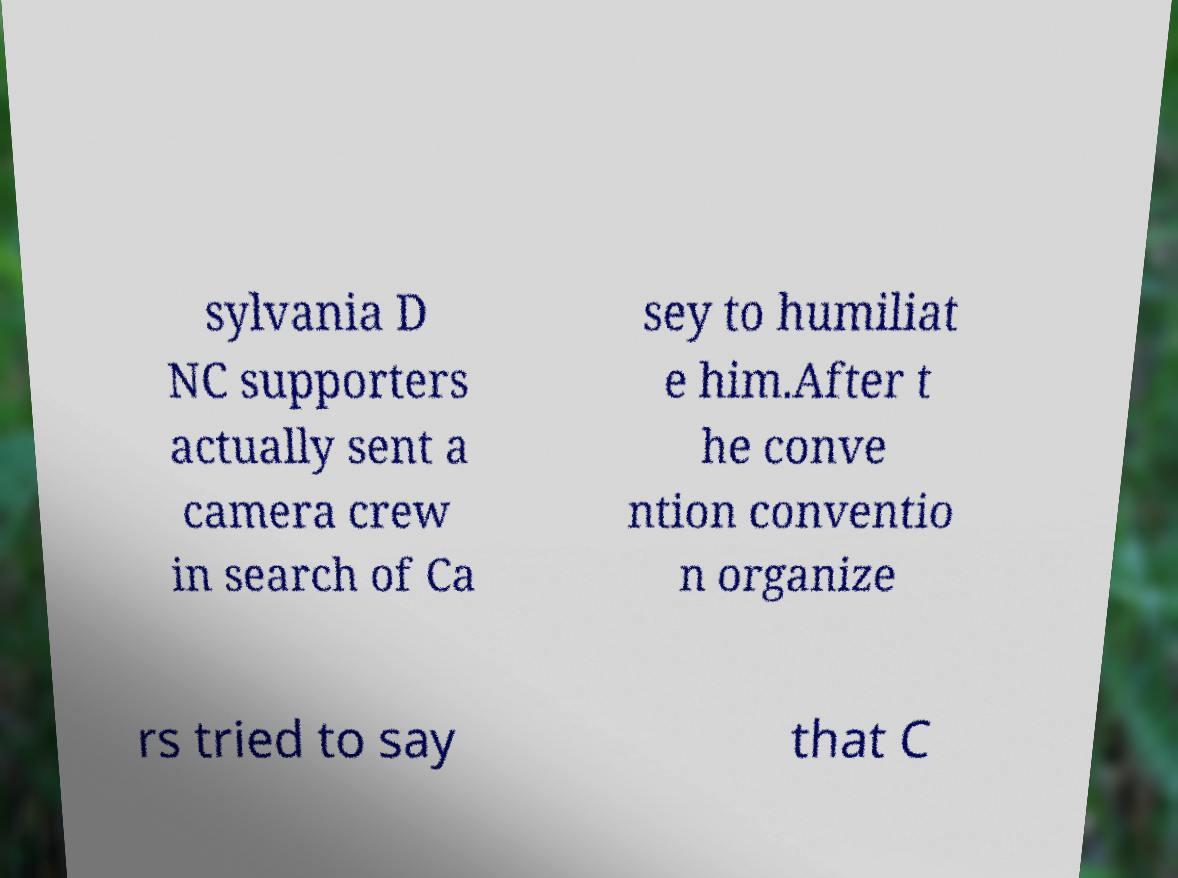There's text embedded in this image that I need extracted. Can you transcribe it verbatim? sylvania D NC supporters actually sent a camera crew in search of Ca sey to humiliat e him.After t he conve ntion conventio n organize rs tried to say that C 